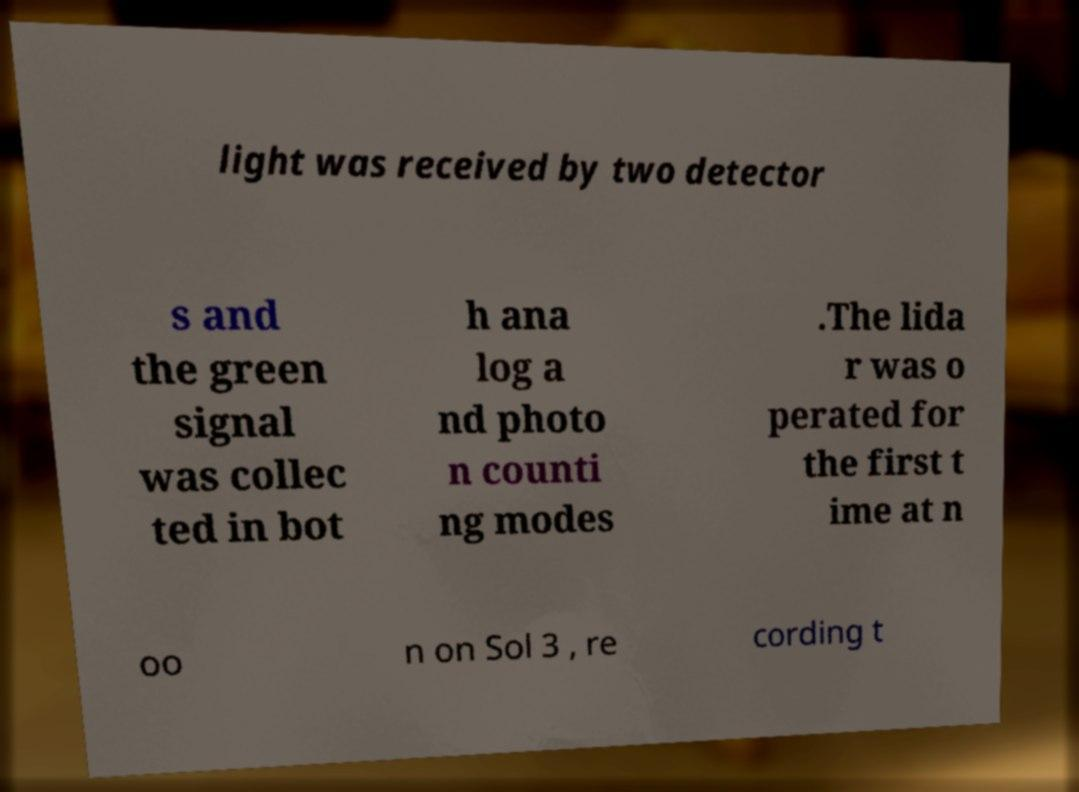There's text embedded in this image that I need extracted. Can you transcribe it verbatim? light was received by two detector s and the green signal was collec ted in bot h ana log a nd photo n counti ng modes .The lida r was o perated for the first t ime at n oo n on Sol 3 , re cording t 